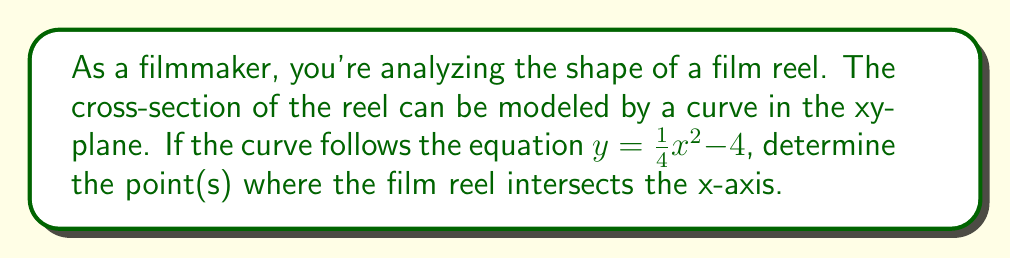Teach me how to tackle this problem. To find where the film reel intersects the x-axis, we need to solve the equation when y = 0:

1) Set y = 0 in the equation:
   $0 = \frac{1}{4}x^2 - 4$

2) Rearrange the equation:
   $4 = \frac{1}{4}x^2$

3) Multiply both sides by 4:
   $16 = x^2$

4) Take the square root of both sides:
   $\pm 4 = x$

5) Therefore, the curve intersects the x-axis at two points: (-4, 0) and (4, 0).

This means the film reel has a diameter of 8 units along the x-axis.

[asy]
import graph;
size(200);
real f(real x) {return (1/4)*x^2 - 4;}
draw(graph(f,-5,5));
draw((-5,0)--(5,0),arrow=Arrow(TeXHead));
draw((0,-5)--(0,2),arrow=Arrow(TeXHead));
dot((-4,0));
dot((4,0));
label("(-4,0)",(-4,0),SW);
label("(4,0)",(4,0),SE);
[/asy]
Answer: $x = \pm 4$ 